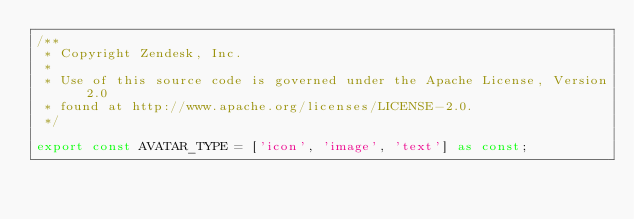Convert code to text. <code><loc_0><loc_0><loc_500><loc_500><_TypeScript_>/**
 * Copyright Zendesk, Inc.
 *
 * Use of this source code is governed under the Apache License, Version 2.0
 * found at http://www.apache.org/licenses/LICENSE-2.0.
 */

export const AVATAR_TYPE = ['icon', 'image', 'text'] as const;
</code> 